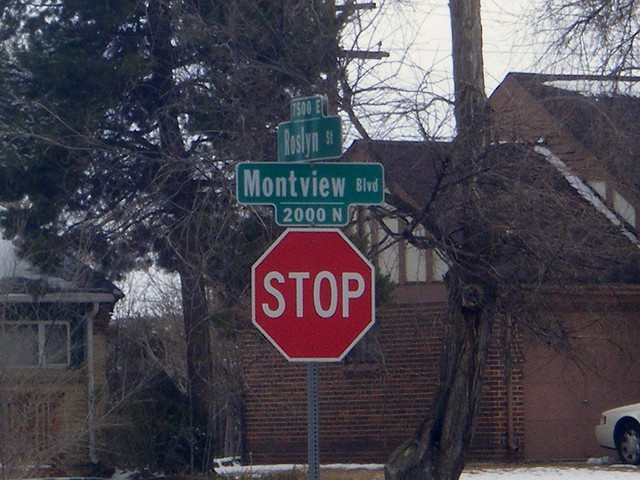Describe the objects in this image and their specific colors. I can see stop sign in darkblue, maroon, brown, and gray tones and car in darkblue, black, gray, and darkgray tones in this image. 